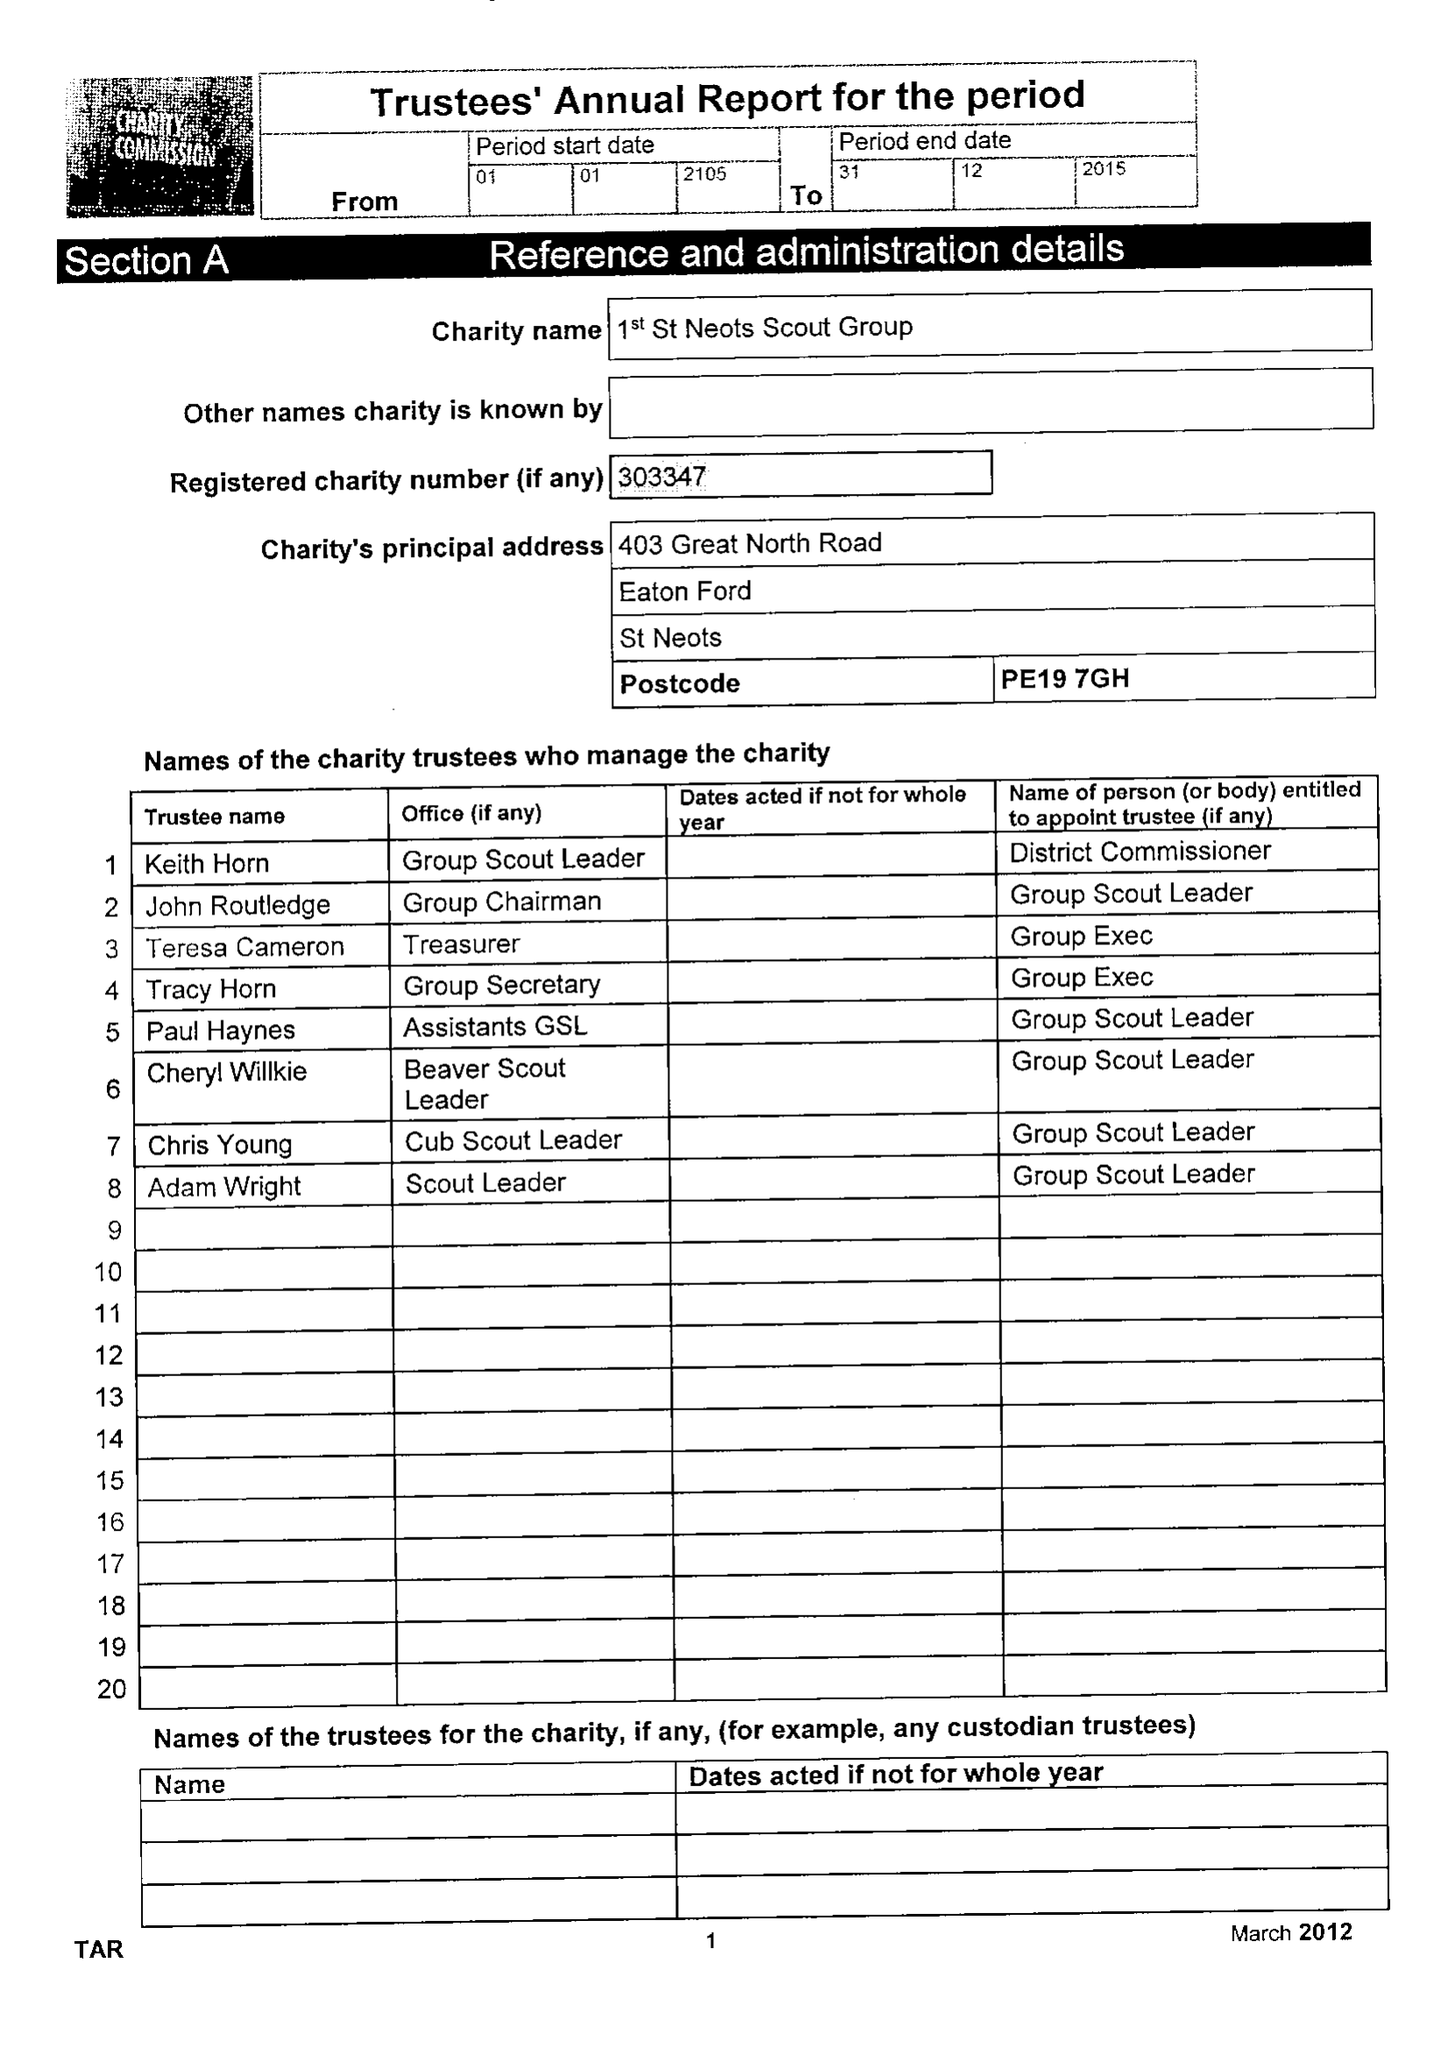What is the value for the income_annually_in_british_pounds?
Answer the question using a single word or phrase. 43127.00 